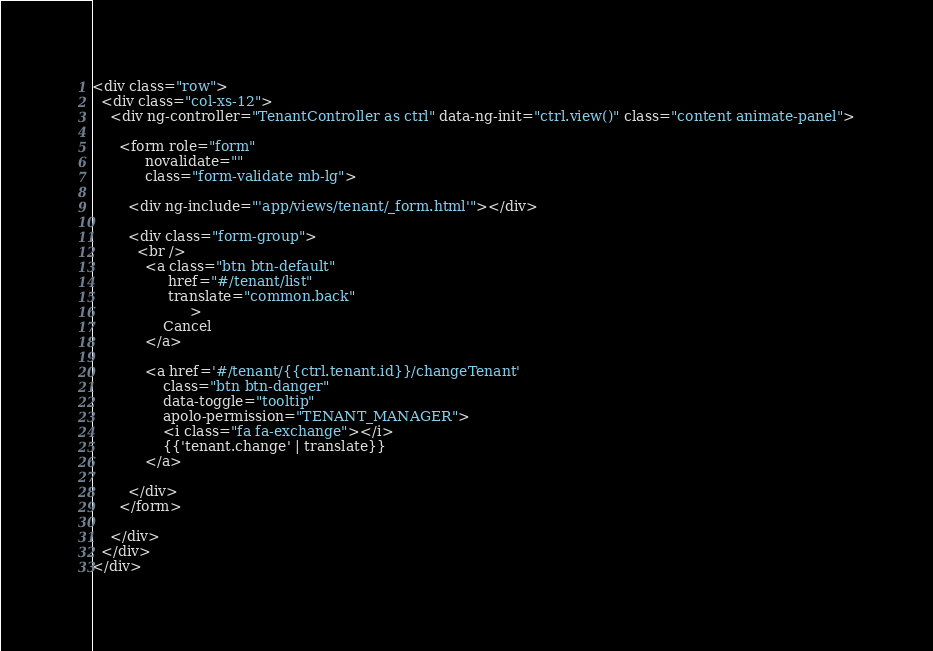<code> <loc_0><loc_0><loc_500><loc_500><_HTML_><div class="row">
  <div class="col-xs-12">
    <div ng-controller="TenantController as ctrl" data-ng-init="ctrl.view()" class="content animate-panel">

      <form role="form"
            novalidate=""
            class="form-validate mb-lg">

        <div ng-include="'app/views/tenant/_form.html'"></div>

        <div class="form-group">
          <br />
            <a class="btn btn-default"
                 href="#/tenant/list"
                 translate="common.back"
                      >
                Cancel
            </a>

            <a href='#/tenant/{{ctrl.tenant.id}}/changeTenant'
                class="btn btn-danger"
                data-toggle="tooltip"
                apolo-permission="TENANT_MANAGER">
                <i class="fa fa-exchange"></i>
                {{'tenant.change' | translate}}
            </a>

        </div>
      </form>

    </div>
  </div>
</div>

</code> 